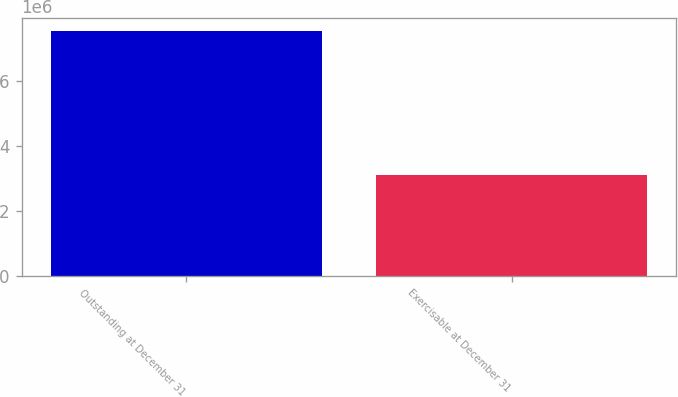Convert chart to OTSL. <chart><loc_0><loc_0><loc_500><loc_500><bar_chart><fcel>Outstanding at December 31<fcel>Exercisable at December 31<nl><fcel>7.54782e+06<fcel>3.11046e+06<nl></chart> 